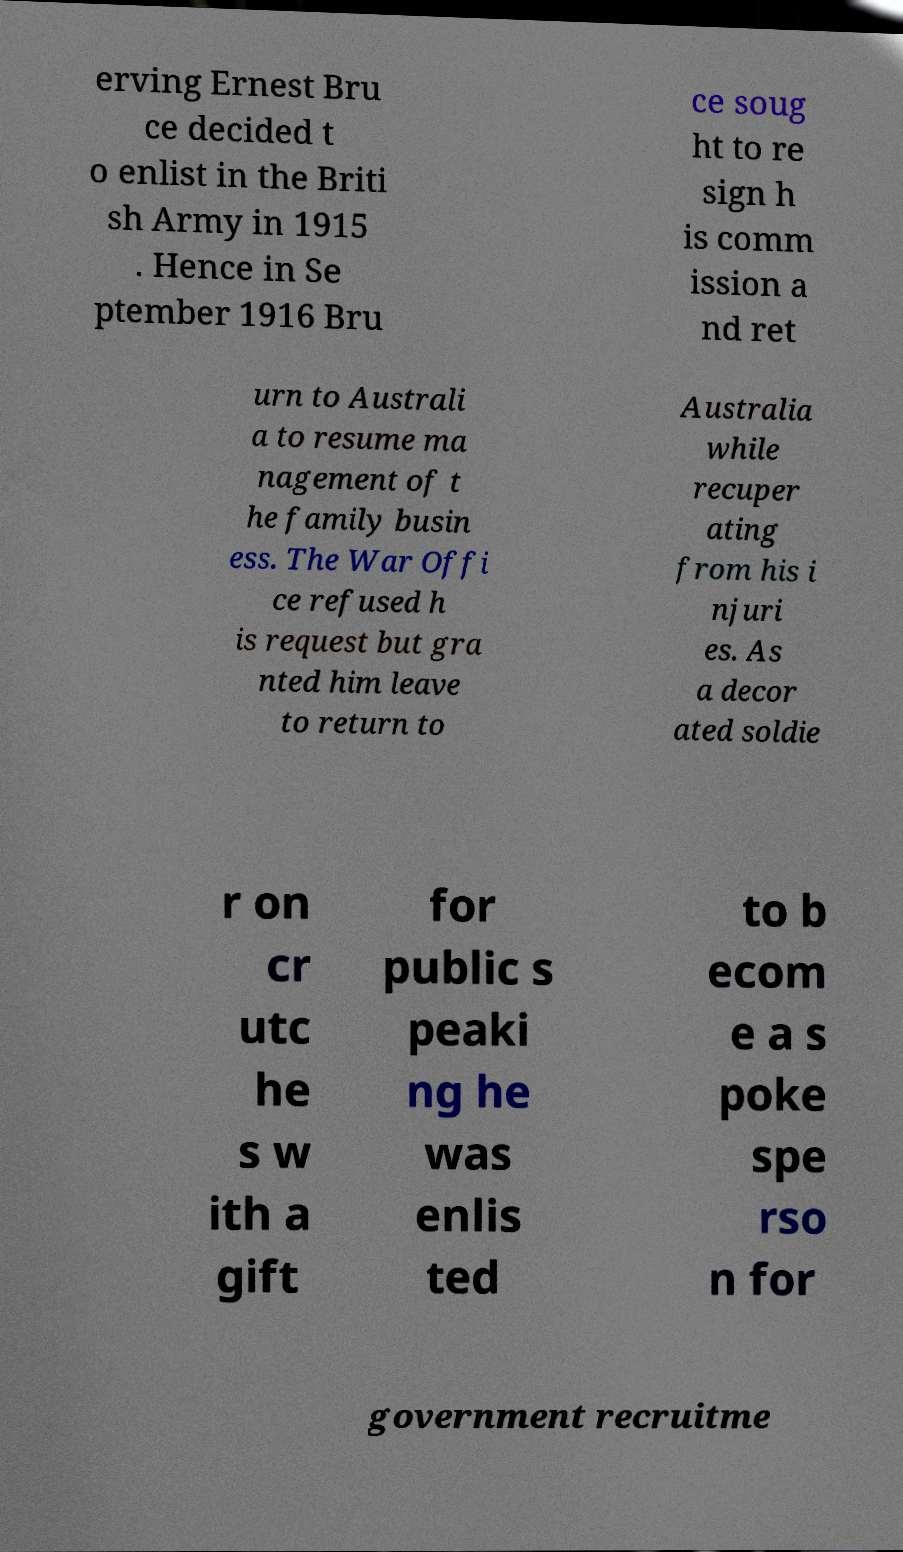Could you extract and type out the text from this image? erving Ernest Bru ce decided t o enlist in the Briti sh Army in 1915 . Hence in Se ptember 1916 Bru ce soug ht to re sign h is comm ission a nd ret urn to Australi a to resume ma nagement of t he family busin ess. The War Offi ce refused h is request but gra nted him leave to return to Australia while recuper ating from his i njuri es. As a decor ated soldie r on cr utc he s w ith a gift for public s peaki ng he was enlis ted to b ecom e a s poke spe rso n for government recruitme 